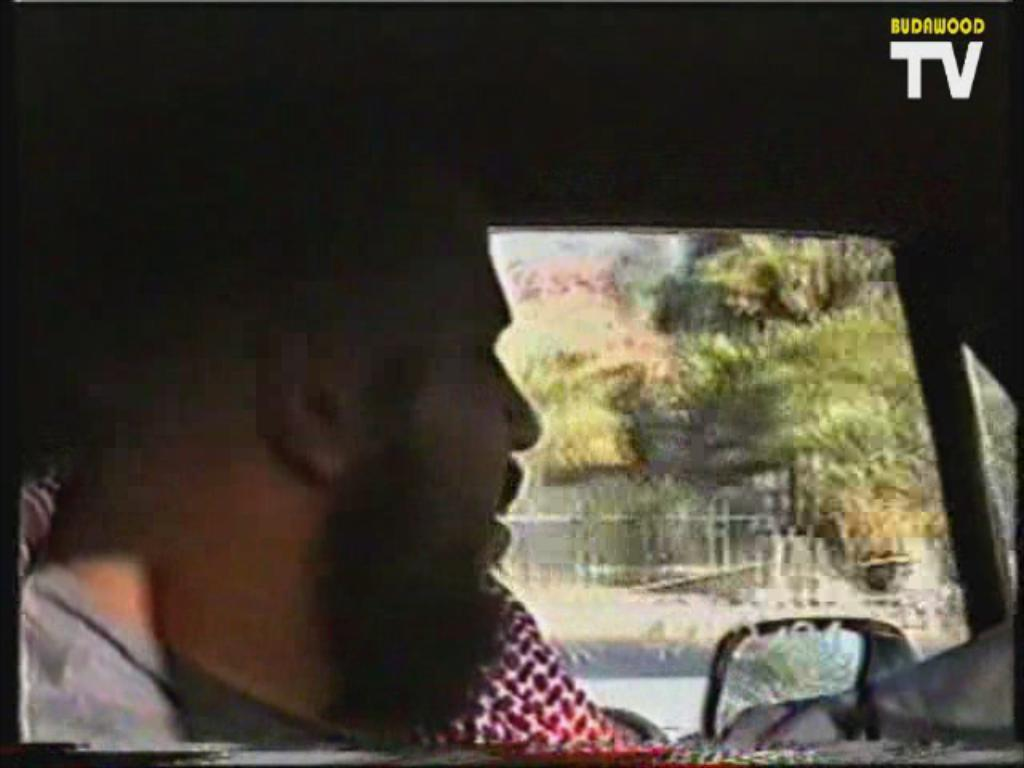Who is present in the image? There is a man in the image. Where is the man located in the image? The man is on the left side of the image. What is the man doing in the image? The man is inside a car. What can be seen in the background of the image? There are trees in the background of the image. What type of cup is the man holding in the image? There is no cup present in the image; the man is inside a car. How does the man feel while sitting in the car in the image? The image does not provide information about the man's feelings, so we cannot determine how he feels. 